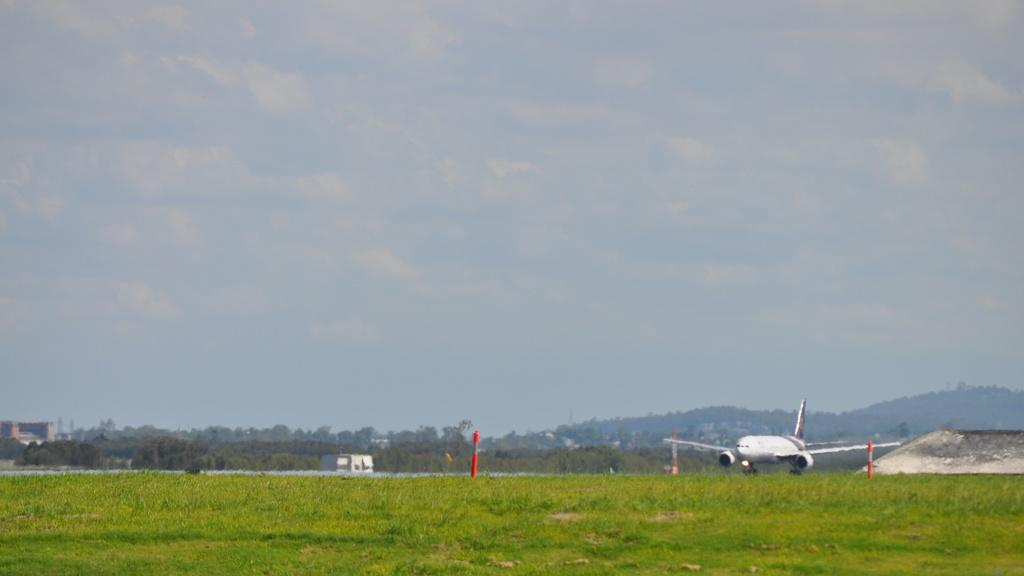What is the main subject of the image? The main subject of the image is an airplane flying. What type of natural vegetation can be seen in the image? There are trees and grass visible in the image. What type of man-made structures are present in the image? There are poles and buildings present in the image. What is visible in the background of the image? The sky with clouds is visible in the background of the image. Can you tell me how many matches are on the page in the image? There are no matches or pages present in the image; it features an airplane flying, trees, grass, poles, buildings, and a sky with clouds. 